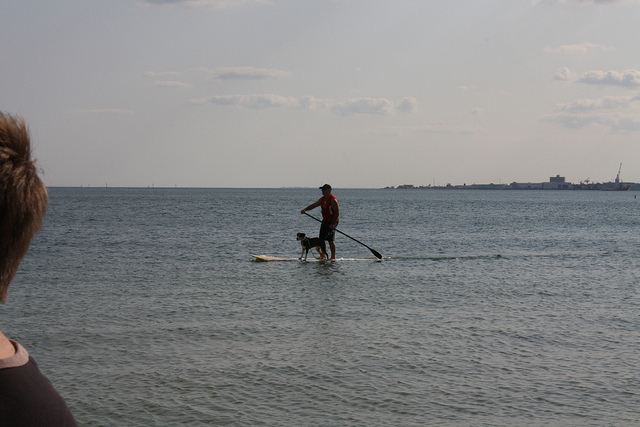<image>Which swimmer has the palest skin? I don't know which swimmer has the palest skin. Which swimmer has the palest skin? It is ambiguous which swimmer has the palest skin. 